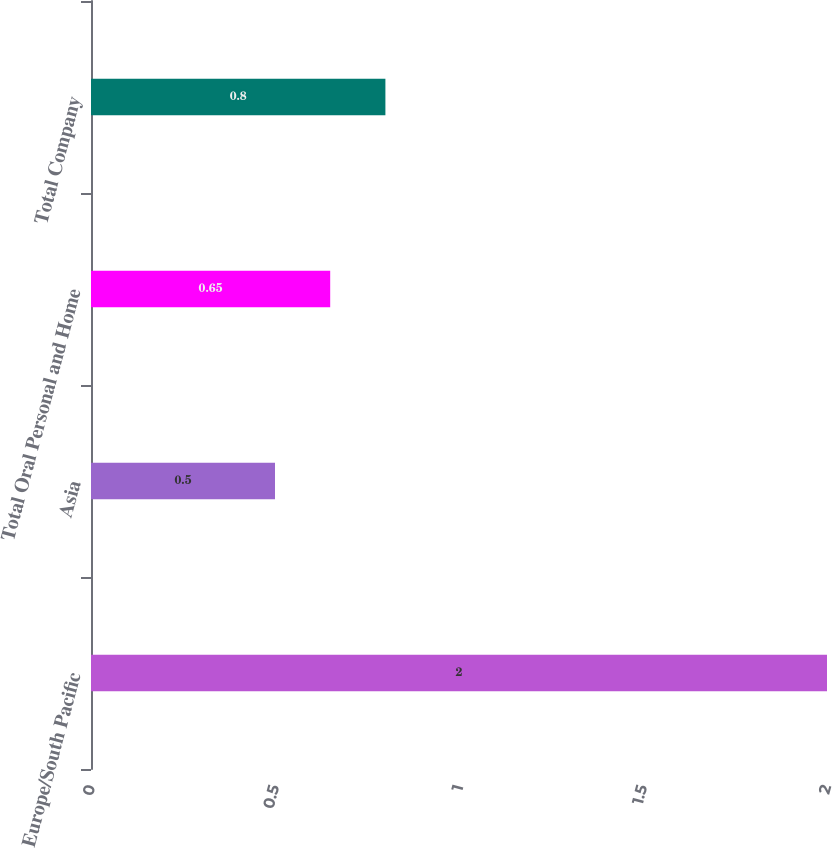<chart> <loc_0><loc_0><loc_500><loc_500><bar_chart><fcel>Europe/South Pacific<fcel>Asia<fcel>Total Oral Personal and Home<fcel>Total Company<nl><fcel>2<fcel>0.5<fcel>0.65<fcel>0.8<nl></chart> 